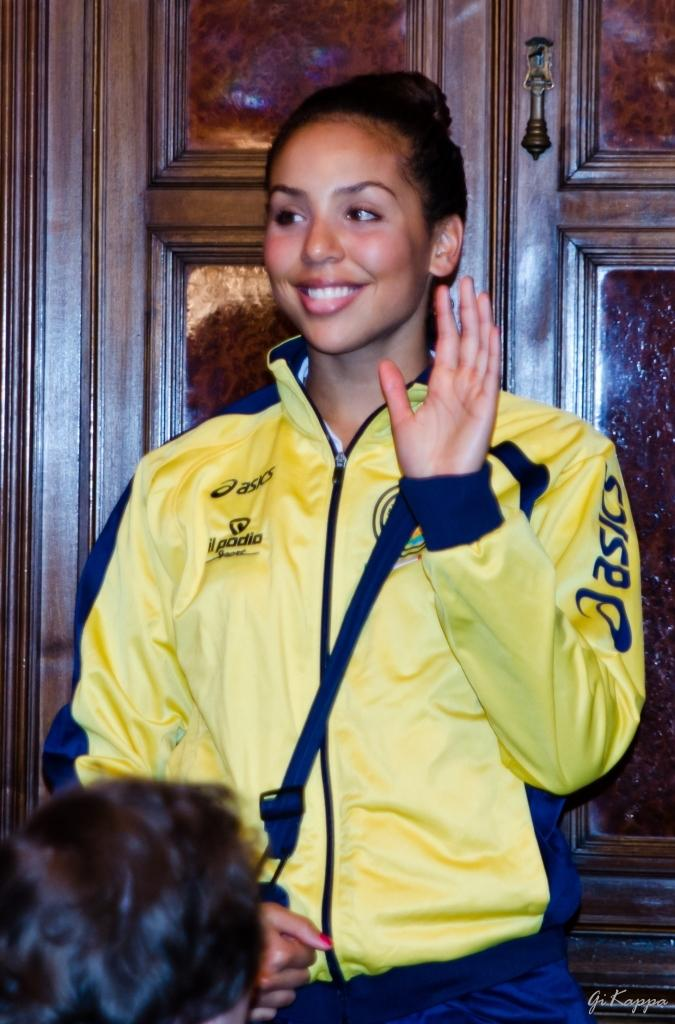<image>
Share a concise interpretation of the image provided. A woman wearing a yellow Asics jacket waves in front of a wooden door. 